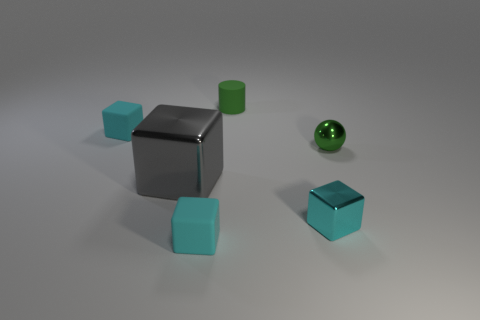Subtract all purple balls. How many cyan blocks are left? 3 Subtract 2 blocks. How many blocks are left? 2 Subtract all cyan cubes. How many cubes are left? 1 Add 1 small cyan rubber blocks. How many objects exist? 7 Subtract all balls. How many objects are left? 5 Add 4 small cyan rubber blocks. How many small cyan rubber blocks exist? 6 Subtract 1 green spheres. How many objects are left? 5 Subtract all tiny green metallic objects. Subtract all tiny matte objects. How many objects are left? 2 Add 4 small cyan objects. How many small cyan objects are left? 7 